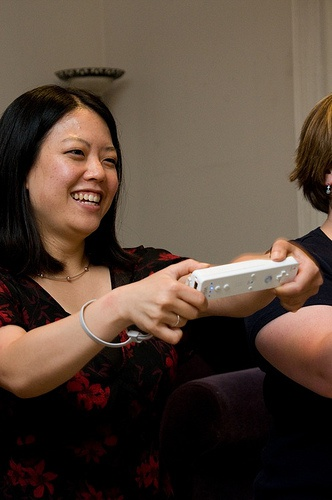Describe the objects in this image and their specific colors. I can see people in gray, black, tan, and maroon tones, people in gray, black, maroon, lightpink, and brown tones, and remote in gray, white, and darkgray tones in this image. 